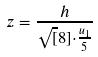Convert formula to latex. <formula><loc_0><loc_0><loc_500><loc_500>z = \frac { h } { \sqrt { [ } 8 ] { \cdot \frac { u _ { 1 } } { 5 } } }</formula> 